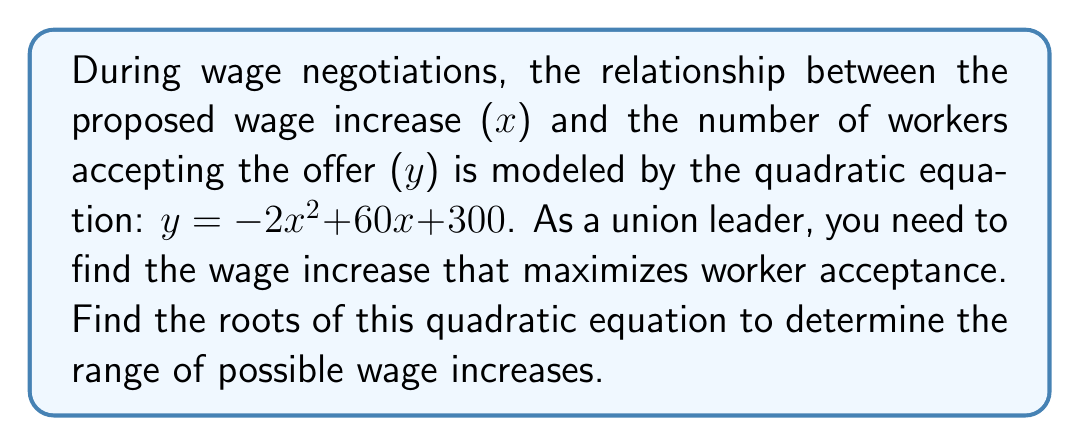Show me your answer to this math problem. To find the roots of the quadratic equation, we need to solve $y = 0$:

1) Set the equation to zero:
   $-2x^2 + 60x + 300 = 0$

2) Divide all terms by -2 to make the leading coefficient 1:
   $x^2 - 30x - 150 = 0$

3) Use the quadratic formula: $x = \frac{-b \pm \sqrt{b^2 - 4ac}}{2a}$
   Where $a = 1$, $b = -30$, and $c = -150$

4) Substitute into the formula:
   $x = \frac{30 \pm \sqrt{(-30)^2 - 4(1)(-150)}}{2(1)}$

5) Simplify:
   $x = \frac{30 \pm \sqrt{900 + 600}}{2} = \frac{30 \pm \sqrt{1500}}{2}$

6) Simplify further:
   $x = \frac{30 \pm 10\sqrt{15}}{2}$

7) Separate the two roots:
   $x_1 = \frac{30 + 10\sqrt{15}}{2} = 15 + 5\sqrt{15}$
   $x_2 = \frac{30 - 10\sqrt{15}}{2} = 15 - 5\sqrt{15}$

The roots represent the minimum and maximum wage increases that would result in zero worker acceptance. The optimal wage increase would be halfway between these roots.
Answer: $x_1 = 15 + 5\sqrt{15}$, $x_2 = 15 - 5\sqrt{15}$ 